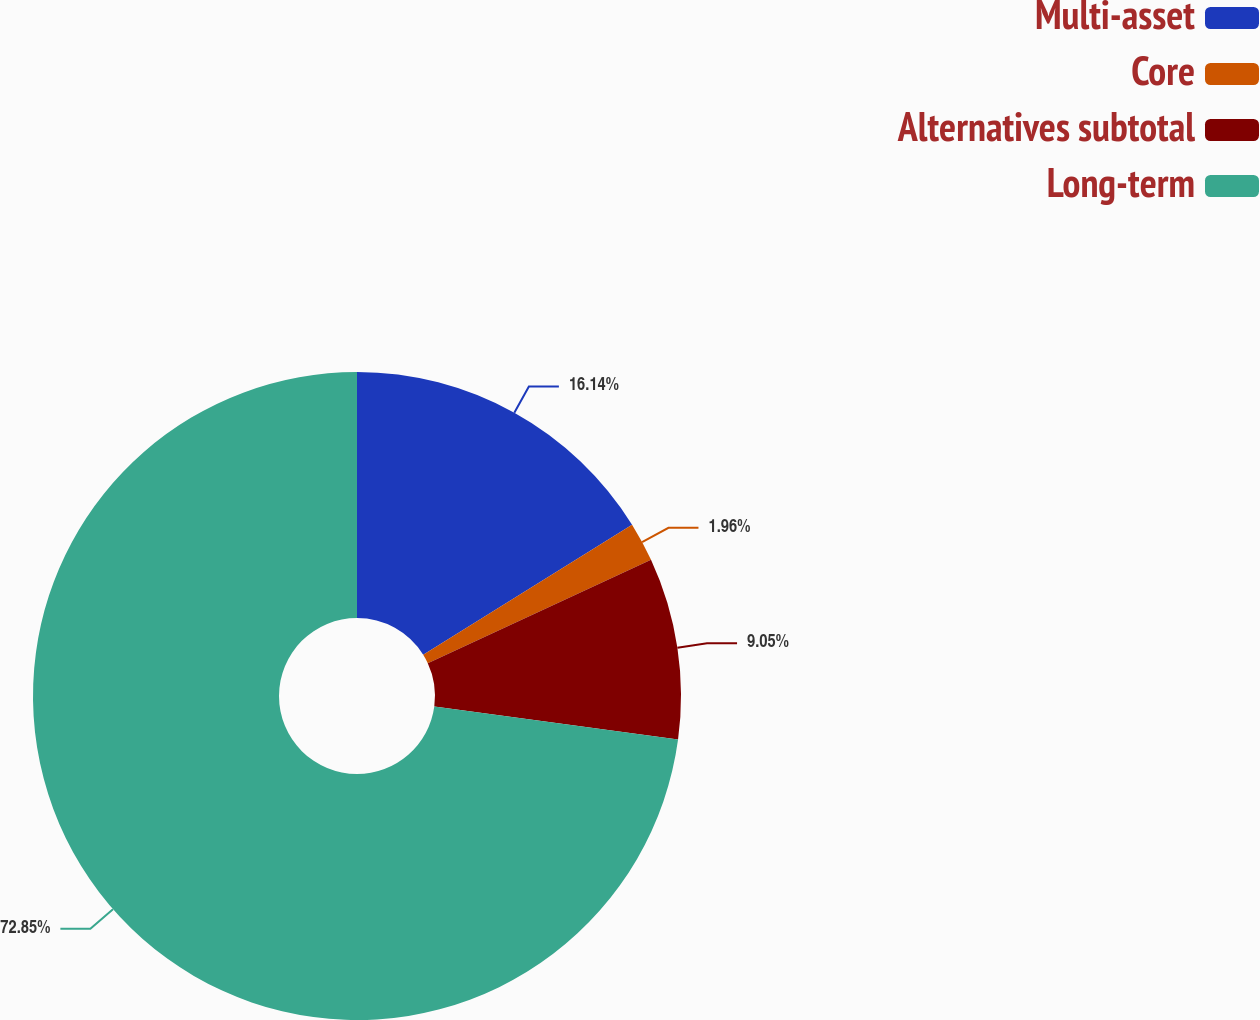Convert chart to OTSL. <chart><loc_0><loc_0><loc_500><loc_500><pie_chart><fcel>Multi-asset<fcel>Core<fcel>Alternatives subtotal<fcel>Long-term<nl><fcel>16.14%<fcel>1.96%<fcel>9.05%<fcel>72.86%<nl></chart> 